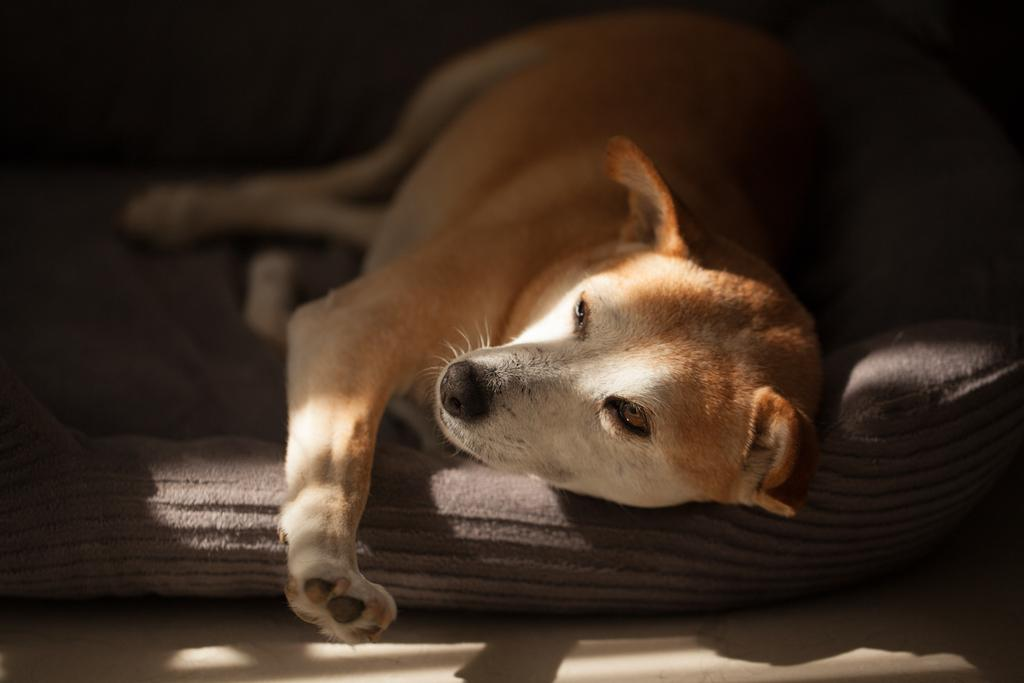What type of animal can be seen in the image? There is a dog in the image. What is the dog doing in the image? The dog is sleeping on a bed. Can you describe the dog's appearance? The dog has brown and white coloring. What color is the bed the dog is sleeping on? The bed is grey in color. What type of shoes is the dog wearing in the image? There are no shoes present in the image, as dogs do not wear shoes. 